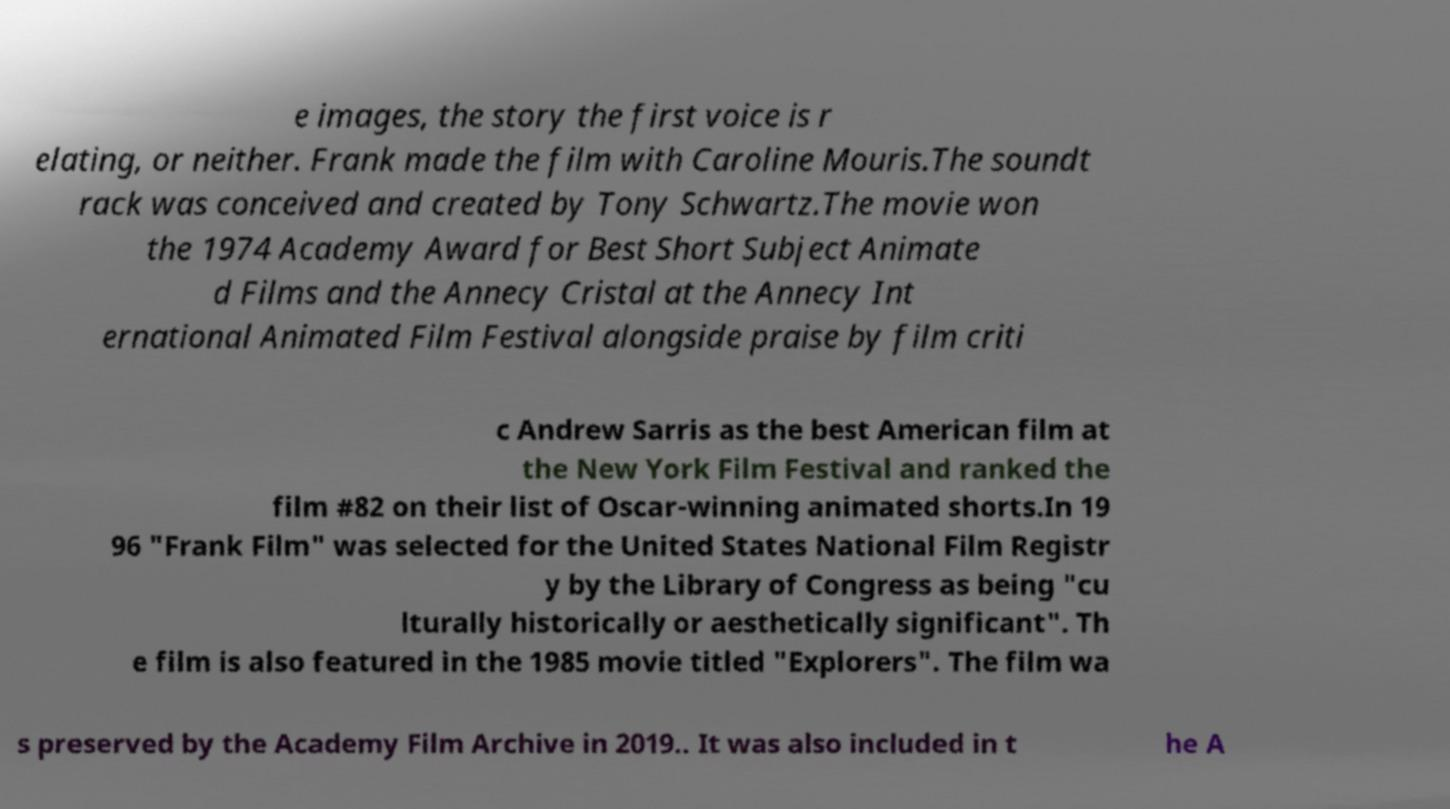I need the written content from this picture converted into text. Can you do that? e images, the story the first voice is r elating, or neither. Frank made the film with Caroline Mouris.The soundt rack was conceived and created by Tony Schwartz.The movie won the 1974 Academy Award for Best Short Subject Animate d Films and the Annecy Cristal at the Annecy Int ernational Animated Film Festival alongside praise by film criti c Andrew Sarris as the best American film at the New York Film Festival and ranked the film #82 on their list of Oscar-winning animated shorts.In 19 96 "Frank Film" was selected for the United States National Film Registr y by the Library of Congress as being "cu lturally historically or aesthetically significant". Th e film is also featured in the 1985 movie titled "Explorers". The film wa s preserved by the Academy Film Archive in 2019.. It was also included in t he A 